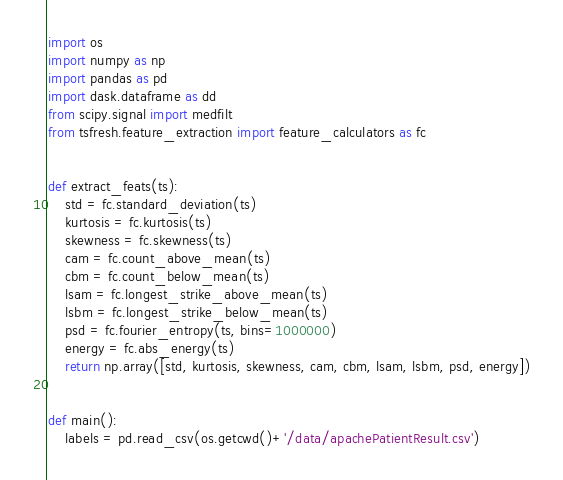Convert code to text. <code><loc_0><loc_0><loc_500><loc_500><_Python_>import os
import numpy as np
import pandas as pd
import dask.dataframe as dd
from scipy.signal import medfilt
from tsfresh.feature_extraction import feature_calculators as fc


def extract_feats(ts):
    std = fc.standard_deviation(ts)
    kurtosis = fc.kurtosis(ts)
    skewness = fc.skewness(ts)
    cam = fc.count_above_mean(ts)
    cbm = fc.count_below_mean(ts)
    lsam = fc.longest_strike_above_mean(ts)
    lsbm = fc.longest_strike_below_mean(ts)
    psd = fc.fourier_entropy(ts, bins=1000000)
    energy = fc.abs_energy(ts)
    return np.array([std, kurtosis, skewness, cam, cbm, lsam, lsbm, psd, energy])


def main():
    labels = pd.read_csv(os.getcwd()+'/data/apachePatientResult.csv')</code> 